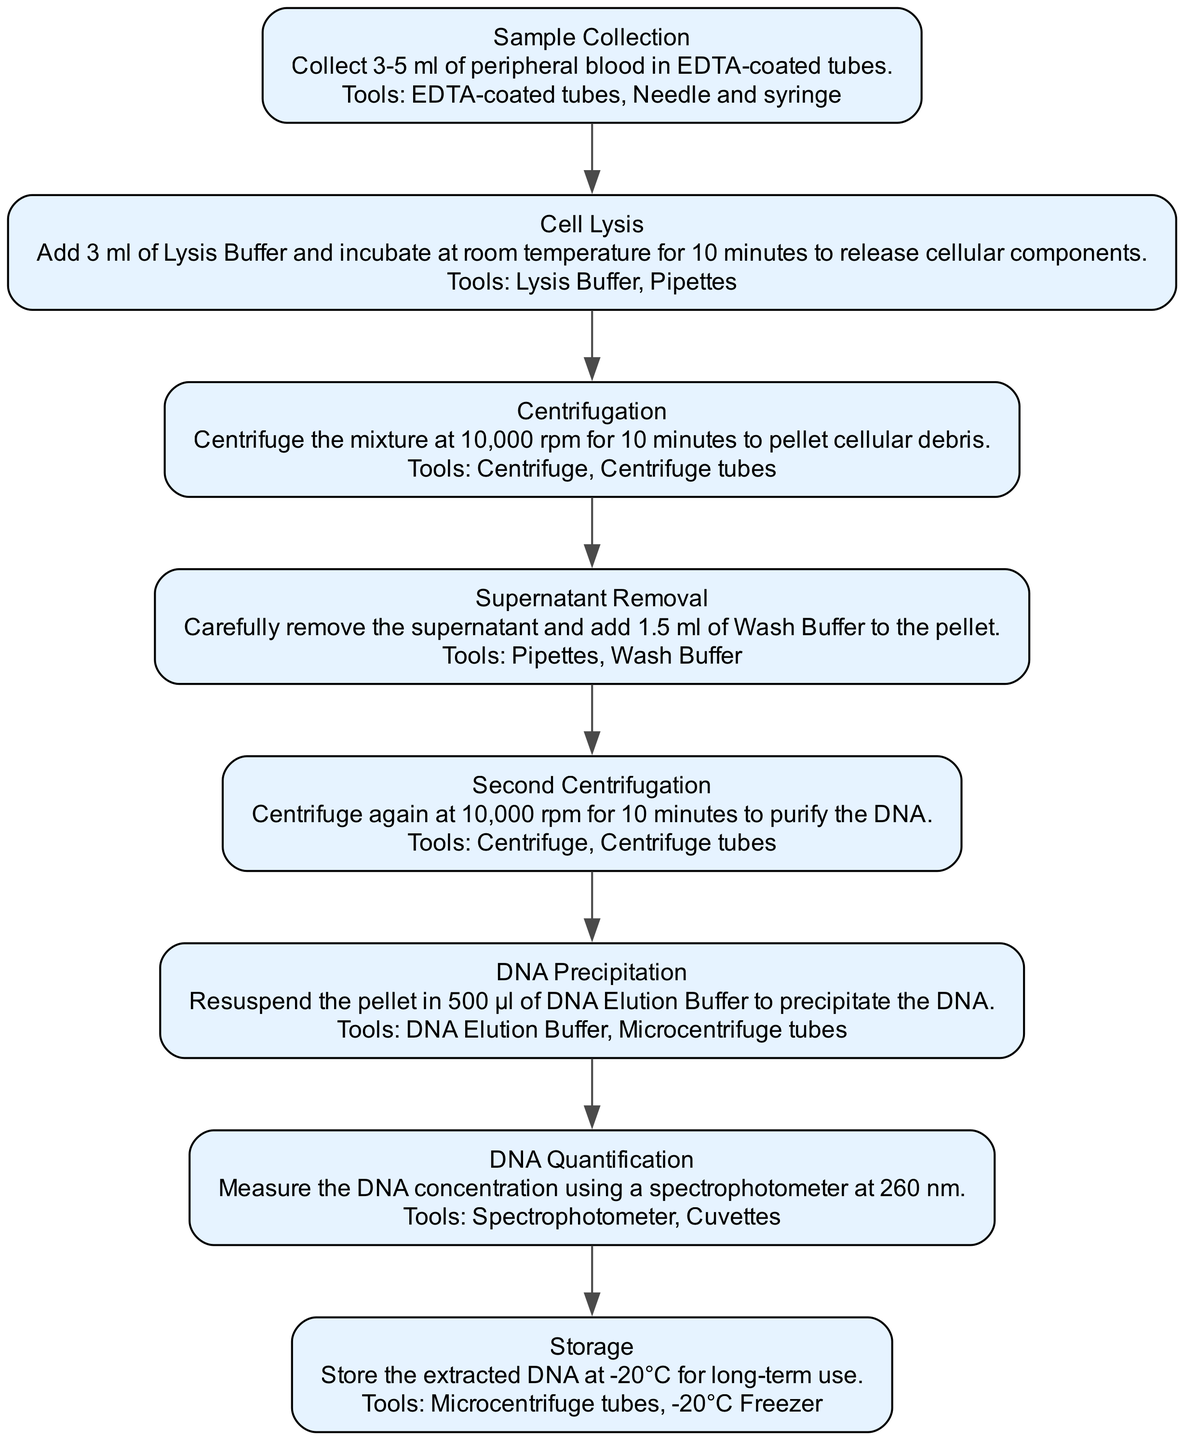What is the first step in the protocol? The first step, as indicated in the diagram, is "Sample Collection". This is clearly identified as the topmost node in the flow, showing the sequential order of steps.
Answer: Sample Collection How many total steps are in the protocol? By counting the nodes in the diagram, there are eight distinct steps shown, each representing a different stage in the DNA extraction process.
Answer: 8 What tools are needed for cell lysis? The node for the "Cell Lysis" step specifies the tools required as "Lysis Buffer" and "Pipettes". These tools are explicitly listed alongside the description of the step.
Answer: Lysis Buffer, Pipettes What is the purpose of the second centrifugation? The diagram states that the purpose of the "Second Centrifugation" is to purify the DNA. This is specified in the corresponding node, linking the step directly to its objective.
Answer: Purify the DNA What temperature should the extracted DNA be stored at? The "Storage" step indicates that the extracted DNA should be stored at -20°C. This is clearly presented in the last node of the flowchart.
Answer: -20°C In which step is DNA quantification performed? The "DNA Quantification" step comes after "DNA Precipitation" and before "Storage". This transition between nodes helps identify where this action occurs in the protocol.
Answer: DNA Quantification What happens during the supernatant removal? During the "Supernatant Removal" step, the supernatant is carefully removed, and 1.5 ml of Wash Buffer is added to the pellet. This description is stated in the node for that particular step, detailing the action taken.
Answer: Carefully remove the supernatant and add 1.5 ml of Wash Buffer What is the RPM used for centrifugation in the protocol? Both instances of "Centrifugation" in the protocol specify an RPM of 10,000. This consistency is noted in both the "Centrifugation" and "Second Centrifugation" steps, indicating a repeated process.
Answer: 10,000 RPM What is required to measure DNA concentration? The "DNA Quantification" step specifies using a "Spectrophotometer" at 260 nm for measuring DNA concentration. This detail indicates the exact tools and measurements needed for this task.
Answer: Spectrophotometer at 260 nm 